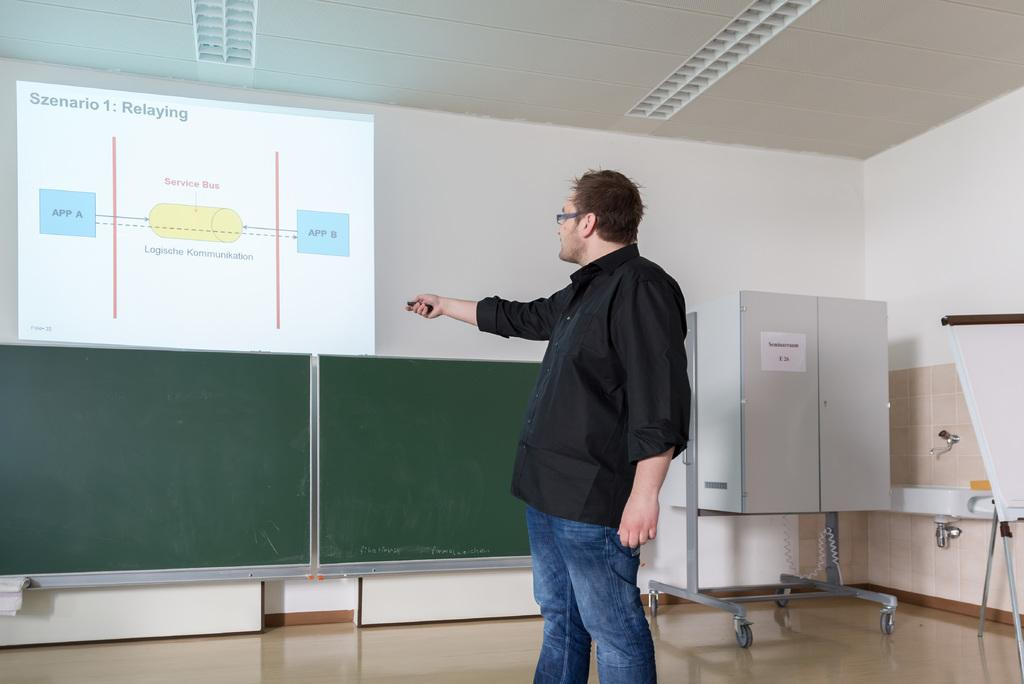<image>
Write a terse but informative summary of the picture. A man is pointing to a screen that says szenario. 